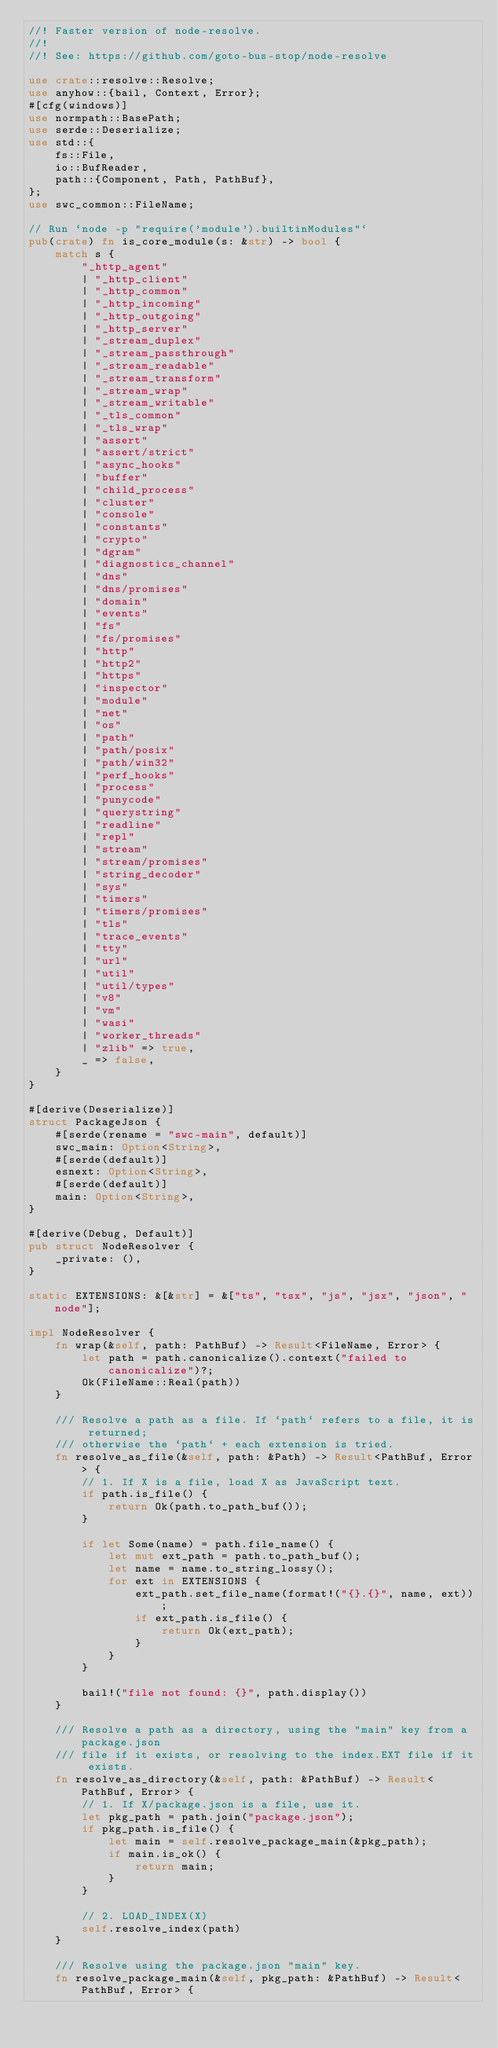Convert code to text. <code><loc_0><loc_0><loc_500><loc_500><_Rust_>//! Faster version of node-resolve.
//!
//! See: https://github.com/goto-bus-stop/node-resolve

use crate::resolve::Resolve;
use anyhow::{bail, Context, Error};
#[cfg(windows)]
use normpath::BasePath;
use serde::Deserialize;
use std::{
    fs::File,
    io::BufReader,
    path::{Component, Path, PathBuf},
};
use swc_common::FileName;

// Run `node -p "require('module').builtinModules"`
pub(crate) fn is_core_module(s: &str) -> bool {
    match s {
        "_http_agent"
        | "_http_client"
        | "_http_common"
        | "_http_incoming"
        | "_http_outgoing"
        | "_http_server"
        | "_stream_duplex"
        | "_stream_passthrough"
        | "_stream_readable"
        | "_stream_transform"
        | "_stream_wrap"
        | "_stream_writable"
        | "_tls_common"
        | "_tls_wrap"
        | "assert"
        | "assert/strict"
        | "async_hooks"
        | "buffer"
        | "child_process"
        | "cluster"
        | "console"
        | "constants"
        | "crypto"
        | "dgram"
        | "diagnostics_channel"
        | "dns"
        | "dns/promises"
        | "domain"
        | "events"
        | "fs"
        | "fs/promises"
        | "http"
        | "http2"
        | "https"
        | "inspector"
        | "module"
        | "net"
        | "os"
        | "path"
        | "path/posix"
        | "path/win32"
        | "perf_hooks"
        | "process"
        | "punycode"
        | "querystring"
        | "readline"
        | "repl"
        | "stream"
        | "stream/promises"
        | "string_decoder"
        | "sys"
        | "timers"
        | "timers/promises"
        | "tls"
        | "trace_events"
        | "tty"
        | "url"
        | "util"
        | "util/types"
        | "v8"
        | "vm"
        | "wasi"
        | "worker_threads"
        | "zlib" => true,
        _ => false,
    }
}

#[derive(Deserialize)]
struct PackageJson {
    #[serde(rename = "swc-main", default)]
    swc_main: Option<String>,
    #[serde(default)]
    esnext: Option<String>,
    #[serde(default)]
    main: Option<String>,
}

#[derive(Debug, Default)]
pub struct NodeResolver {
    _private: (),
}

static EXTENSIONS: &[&str] = &["ts", "tsx", "js", "jsx", "json", "node"];

impl NodeResolver {
    fn wrap(&self, path: PathBuf) -> Result<FileName, Error> {
        let path = path.canonicalize().context("failed to canonicalize")?;
        Ok(FileName::Real(path))
    }

    /// Resolve a path as a file. If `path` refers to a file, it is returned;
    /// otherwise the `path` + each extension is tried.
    fn resolve_as_file(&self, path: &Path) -> Result<PathBuf, Error> {
        // 1. If X is a file, load X as JavaScript text.
        if path.is_file() {
            return Ok(path.to_path_buf());
        }

        if let Some(name) = path.file_name() {
            let mut ext_path = path.to_path_buf();
            let name = name.to_string_lossy();
            for ext in EXTENSIONS {
                ext_path.set_file_name(format!("{}.{}", name, ext));
                if ext_path.is_file() {
                    return Ok(ext_path);
                }
            }
        }

        bail!("file not found: {}", path.display())
    }

    /// Resolve a path as a directory, using the "main" key from a package.json
    /// file if it exists, or resolving to the index.EXT file if it exists.
    fn resolve_as_directory(&self, path: &PathBuf) -> Result<PathBuf, Error> {
        // 1. If X/package.json is a file, use it.
        let pkg_path = path.join("package.json");
        if pkg_path.is_file() {
            let main = self.resolve_package_main(&pkg_path);
            if main.is_ok() {
                return main;
            }
        }

        // 2. LOAD_INDEX(X)
        self.resolve_index(path)
    }

    /// Resolve using the package.json "main" key.
    fn resolve_package_main(&self, pkg_path: &PathBuf) -> Result<PathBuf, Error> {</code> 